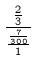<formula> <loc_0><loc_0><loc_500><loc_500>\frac { \frac { 2 } { 3 } } { \frac { \frac { 7 } { 3 0 0 } } { 1 } }</formula> 